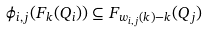<formula> <loc_0><loc_0><loc_500><loc_500>\phi _ { i , j } ( F _ { k } ( Q _ { i } ) ) \subseteq F _ { w _ { i , j } ( k ) - k } ( Q _ { j } )</formula> 